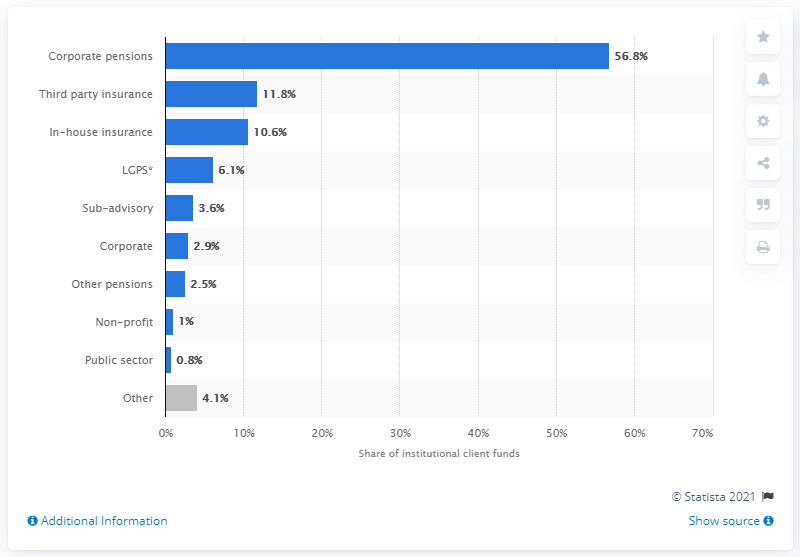Specify some key components in this picture. The highest distribution of institutional clients' funds on the investment market in the UK as of December 2019, by client type, was found to be in the corporate pensions sector, with the majority of funds invested in this sector. I'm sorry, but I'm not sure what you're asking. Could you please clarify or provide more context so I can better understand and provide a helpful response? 